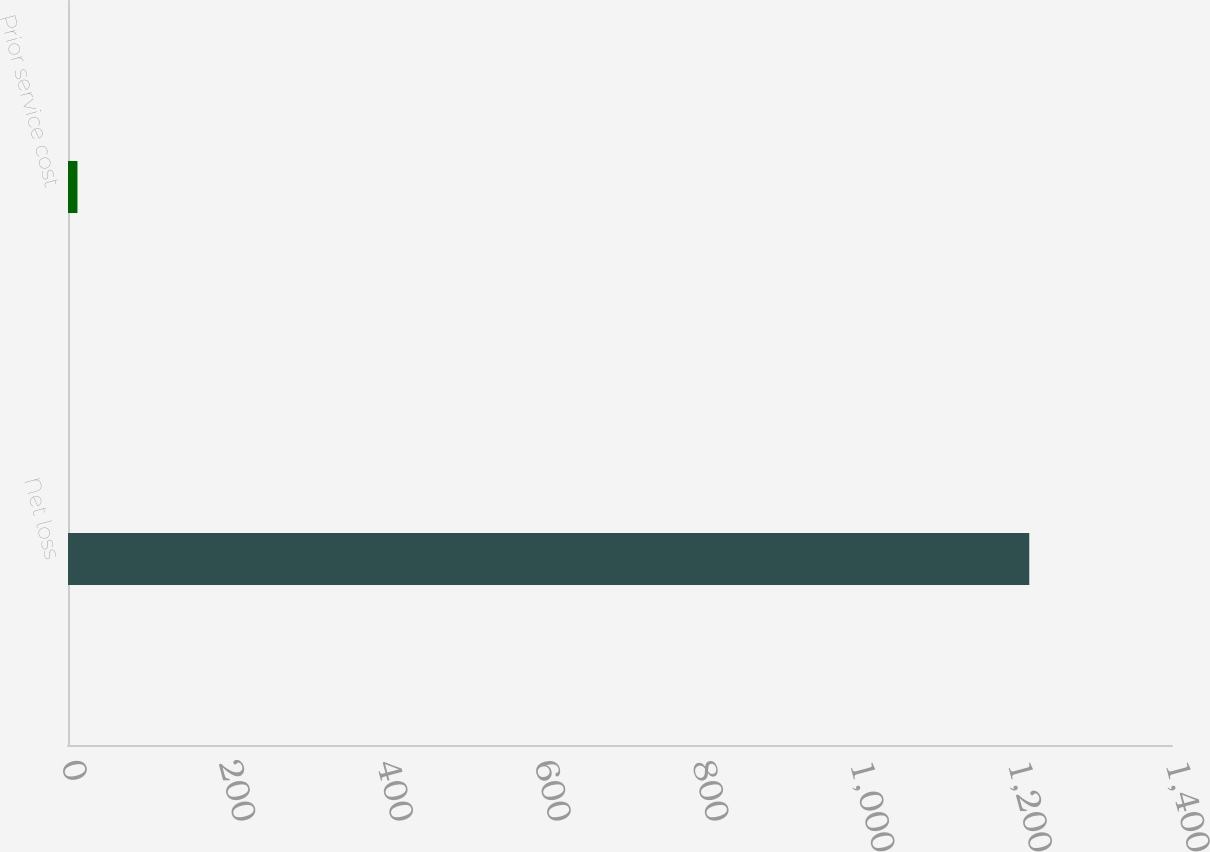Convert chart. <chart><loc_0><loc_0><loc_500><loc_500><bar_chart><fcel>Net loss<fcel>Prior service cost<nl><fcel>1219<fcel>12<nl></chart> 